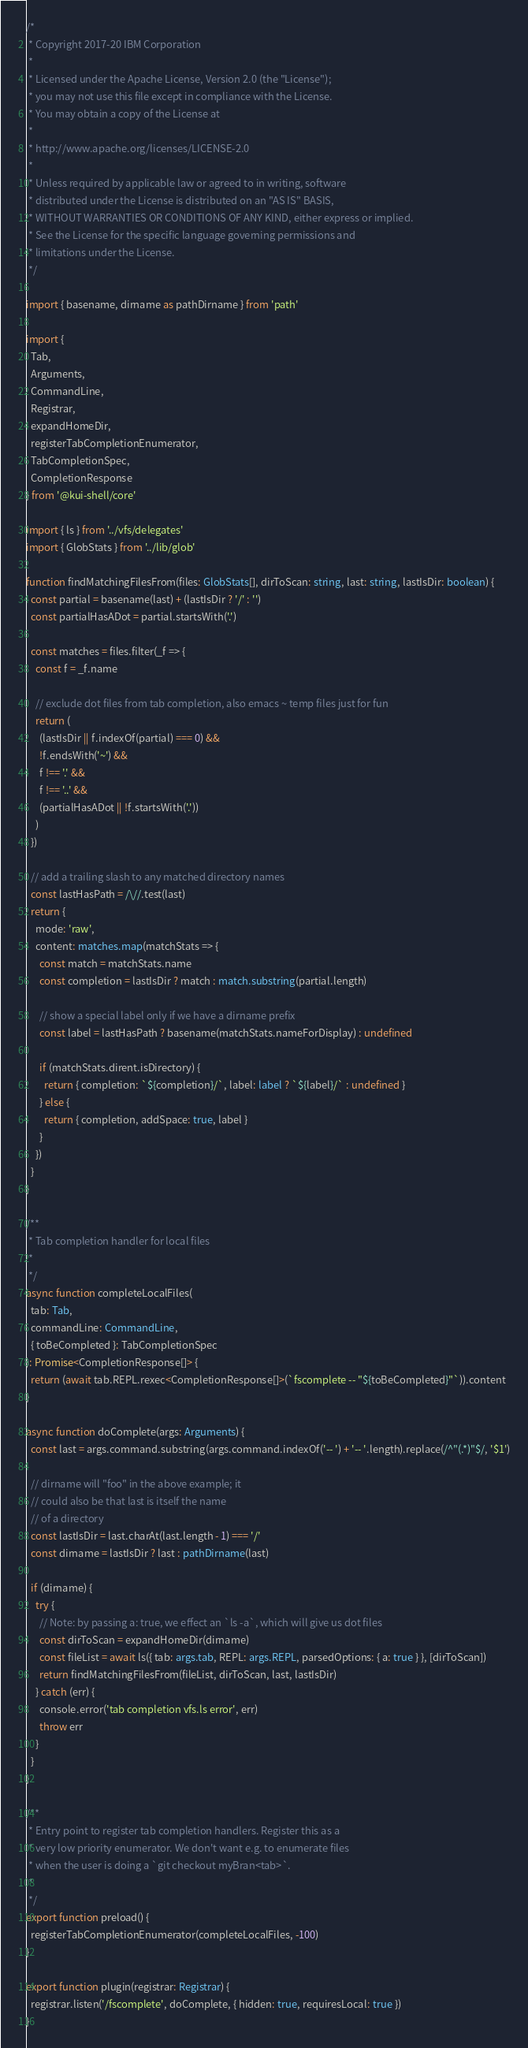Convert code to text. <code><loc_0><loc_0><loc_500><loc_500><_TypeScript_>/*
 * Copyright 2017-20 IBM Corporation
 *
 * Licensed under the Apache License, Version 2.0 (the "License");
 * you may not use this file except in compliance with the License.
 * You may obtain a copy of the License at
 *
 * http://www.apache.org/licenses/LICENSE-2.0
 *
 * Unless required by applicable law or agreed to in writing, software
 * distributed under the License is distributed on an "AS IS" BASIS,
 * WITHOUT WARRANTIES OR CONDITIONS OF ANY KIND, either express or implied.
 * See the License for the specific language governing permissions and
 * limitations under the License.
 */

import { basename, dirname as pathDirname } from 'path'

import {
  Tab,
  Arguments,
  CommandLine,
  Registrar,
  expandHomeDir,
  registerTabCompletionEnumerator,
  TabCompletionSpec,
  CompletionResponse
} from '@kui-shell/core'

import { ls } from '../vfs/delegates'
import { GlobStats } from '../lib/glob'

function findMatchingFilesFrom(files: GlobStats[], dirToScan: string, last: string, lastIsDir: boolean) {
  const partial = basename(last) + (lastIsDir ? '/' : '')
  const partialHasADot = partial.startsWith('.')

  const matches = files.filter(_f => {
    const f = _f.name

    // exclude dot files from tab completion, also emacs ~ temp files just for fun
    return (
      (lastIsDir || f.indexOf(partial) === 0) &&
      !f.endsWith('~') &&
      f !== '.' &&
      f !== '..' &&
      (partialHasADot || !f.startsWith('.'))
    )
  })

  // add a trailing slash to any matched directory names
  const lastHasPath = /\//.test(last)
  return {
    mode: 'raw',
    content: matches.map(matchStats => {
      const match = matchStats.name
      const completion = lastIsDir ? match : match.substring(partial.length)

      // show a special label only if we have a dirname prefix
      const label = lastHasPath ? basename(matchStats.nameForDisplay) : undefined

      if (matchStats.dirent.isDirectory) {
        return { completion: `${completion}/`, label: label ? `${label}/` : undefined }
      } else {
        return { completion, addSpace: true, label }
      }
    })
  }
}

/**
 * Tab completion handler for local files
 *
 */
async function completeLocalFiles(
  tab: Tab,
  commandLine: CommandLine,
  { toBeCompleted }: TabCompletionSpec
): Promise<CompletionResponse[]> {
  return (await tab.REPL.rexec<CompletionResponse[]>(`fscomplete -- "${toBeCompleted}"`)).content
}

async function doComplete(args: Arguments) {
  const last = args.command.substring(args.command.indexOf('-- ') + '-- '.length).replace(/^"(.*)"$/, '$1')

  // dirname will "foo" in the above example; it
  // could also be that last is itself the name
  // of a directory
  const lastIsDir = last.charAt(last.length - 1) === '/'
  const dirname = lastIsDir ? last : pathDirname(last)

  if (dirname) {
    try {
      // Note: by passing a: true, we effect an `ls -a`, which will give us dot files
      const dirToScan = expandHomeDir(dirname)
      const fileList = await ls({ tab: args.tab, REPL: args.REPL, parsedOptions: { a: true } }, [dirToScan])
      return findMatchingFilesFrom(fileList, dirToScan, last, lastIsDir)
    } catch (err) {
      console.error('tab completion vfs.ls error', err)
      throw err
    }
  }
}

/**
 * Entry point to register tab completion handlers. Register this as a
 * very low priority enumerator. We don't want e.g. to enumerate files
 * when the user is doing a `git checkout myBran<tab>`.
 *
 */
export function preload() {
  registerTabCompletionEnumerator(completeLocalFiles, -100)
}

export function plugin(registrar: Registrar) {
  registrar.listen('/fscomplete', doComplete, { hidden: true, requiresLocal: true })
}
</code> 